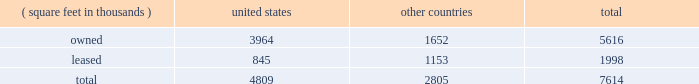Item 2 : properties information concerning applied 2019s properties is set forth below: .
Because of the interrelation of applied 2019s operations , properties within a country may be shared by the segments operating within that country .
The company 2019s headquarters offices are in santa clara , california .
Products in semiconductor systems are manufactured in santa clara , california ; austin , texas ; gloucester , massachusetts ; kalispell , montana ; rehovot , israel ; and singapore .
Remanufactured equipment products in the applied global services segment are produced primarily in austin , texas .
Products in the display and adjacent markets segment are manufactured in alzenau , germany ; and tainan , taiwan .
Other products are manufactured in treviso , italy .
Applied also owns and leases offices , plants and warehouse locations in many locations throughout the world , including in europe , japan , north america ( principally the united states ) , israel , china , india , korea , southeast asia and taiwan .
These facilities are principally used for manufacturing ; research , development and engineering ; and marketing , sales and customer support .
Applied also owns a total of approximately 269 acres of buildable land in montana , texas , california , israel and italy that could accommodate additional building space .
Applied considers the properties that it owns or leases as adequate to meet its current and future requirements .
Applied regularly assesses the size , capability and location of its global infrastructure and periodically makes adjustments based on these assessments. .
How much square feet could the company use to build properies ? ( 1 acre = 43560 square feet )? 
Rationale: the company is able to build properties on the 269 acres that are owned by the company . that is 1.1 million square feet which is calculated by multiplying the number of acres by the conversion of square feet .
Computations: ((269 * 43560) / 100000)
Answer: 117.1764. 